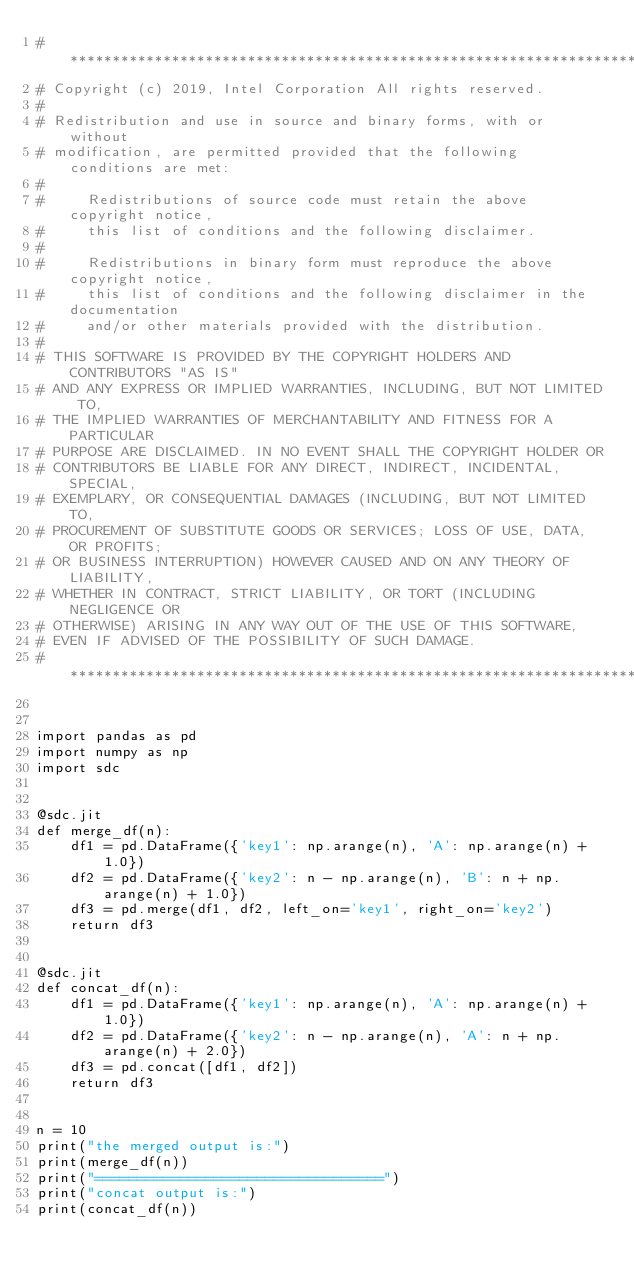<code> <loc_0><loc_0><loc_500><loc_500><_Python_># *****************************************************************************
# Copyright (c) 2019, Intel Corporation All rights reserved.
#
# Redistribution and use in source and binary forms, with or without
# modification, are permitted provided that the following conditions are met:
#
#     Redistributions of source code must retain the above copyright notice,
#     this list of conditions and the following disclaimer.
#
#     Redistributions in binary form must reproduce the above copyright notice,
#     this list of conditions and the following disclaimer in the documentation
#     and/or other materials provided with the distribution.
#
# THIS SOFTWARE IS PROVIDED BY THE COPYRIGHT HOLDERS AND CONTRIBUTORS "AS IS"
# AND ANY EXPRESS OR IMPLIED WARRANTIES, INCLUDING, BUT NOT LIMITED TO,
# THE IMPLIED WARRANTIES OF MERCHANTABILITY AND FITNESS FOR A PARTICULAR
# PURPOSE ARE DISCLAIMED. IN NO EVENT SHALL THE COPYRIGHT HOLDER OR
# CONTRIBUTORS BE LIABLE FOR ANY DIRECT, INDIRECT, INCIDENTAL, SPECIAL,
# EXEMPLARY, OR CONSEQUENTIAL DAMAGES (INCLUDING, BUT NOT LIMITED TO,
# PROCUREMENT OF SUBSTITUTE GOODS OR SERVICES; LOSS OF USE, DATA, OR PROFITS;
# OR BUSINESS INTERRUPTION) HOWEVER CAUSED AND ON ANY THEORY OF LIABILITY,
# WHETHER IN CONTRACT, STRICT LIABILITY, OR TORT (INCLUDING NEGLIGENCE OR
# OTHERWISE) ARISING IN ANY WAY OUT OF THE USE OF THIS SOFTWARE,
# EVEN IF ADVISED OF THE POSSIBILITY OF SUCH DAMAGE.
# *****************************************************************************


import pandas as pd
import numpy as np
import sdc


@sdc.jit
def merge_df(n):
    df1 = pd.DataFrame({'key1': np.arange(n), 'A': np.arange(n) + 1.0})
    df2 = pd.DataFrame({'key2': n - np.arange(n), 'B': n + np.arange(n) + 1.0})
    df3 = pd.merge(df1, df2, left_on='key1', right_on='key2')
    return df3


@sdc.jit
def concat_df(n):
    df1 = pd.DataFrame({'key1': np.arange(n), 'A': np.arange(n) + 1.0})
    df2 = pd.DataFrame({'key2': n - np.arange(n), 'A': n + np.arange(n) + 2.0})
    df3 = pd.concat([df1, df2])
    return df3


n = 10
print("the merged output is:")
print(merge_df(n))
print("==================================")
print("concat output is:")
print(concat_df(n))
</code> 